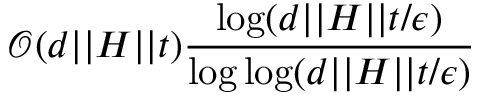Convert formula to latex. <formula><loc_0><loc_0><loc_500><loc_500>\mathcal { O } ( d | | H | | t ) \frac { \log ( d | | H | | t / \epsilon ) } { \log \log ( d | | H | | t / \epsilon ) }</formula> 